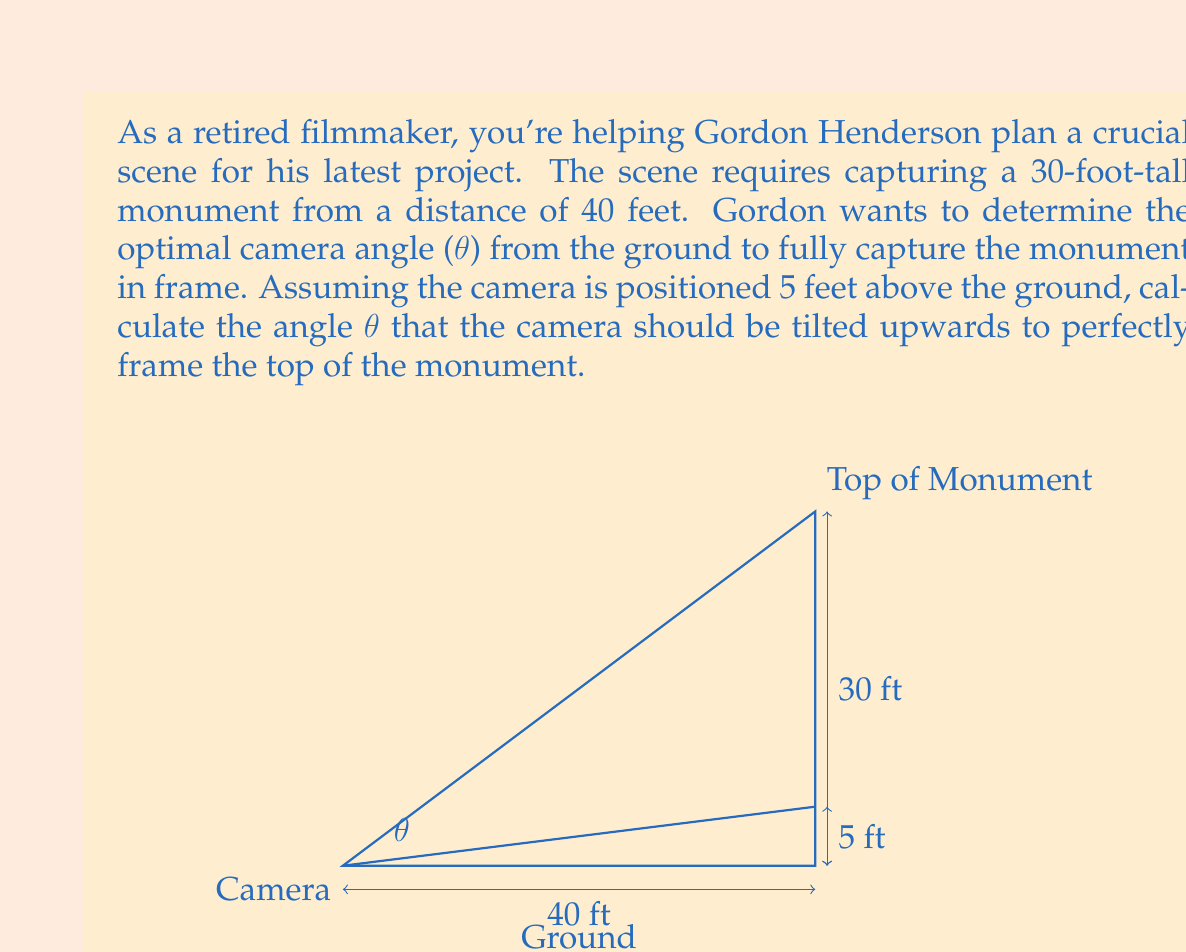Give your solution to this math problem. Let's approach this step-by-step using trigonometry:

1) First, we need to consider the right triangle formed by the camera, the top of the monument, and the ground.

2) The base of this triangle is 40 feet (the distance to the monument).

3) The height of this triangle is not just the height of the monument (30 feet), but also includes the height of the camera (5 feet). So the total height difference is 30 - 5 = 25 feet.

4) We can use the tangent function to find the angle θ. In a right triangle, tangent of an angle is the opposite side divided by the adjacent side.

5) In this case:
   $\tan(\theta) = \frac{\text{opposite}}{\text{adjacent}} = \frac{\text{height difference}}{\text{distance}} = \frac{25}{40}$

6) To find θ, we need to use the inverse tangent (arctangent) function:

   $\theta = \arctan(\frac{25}{40})$

7) Using a calculator or computer:

   $\theta = \arctan(0.625) \approx 32.0054°$

Therefore, the camera should be tilted upwards at an angle of approximately 32.0054° from the horizontal to perfectly frame the top of the monument.
Answer: $\theta \approx 32.0054°$ 